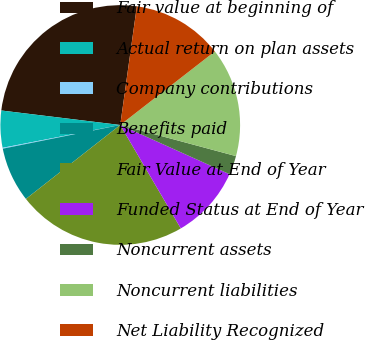<chart> <loc_0><loc_0><loc_500><loc_500><pie_chart><fcel>Fair value at beginning of<fcel>Actual return on plan assets<fcel>Company contributions<fcel>Benefits paid<fcel>Fair Value at End of Year<fcel>Funded Status at End of Year<fcel>Noncurrent assets<fcel>Noncurrent liabilities<fcel>Net Liability Recognized<nl><fcel>25.28%<fcel>4.98%<fcel>0.12%<fcel>7.41%<fcel>22.85%<fcel>9.84%<fcel>2.55%<fcel>14.7%<fcel>12.27%<nl></chart> 